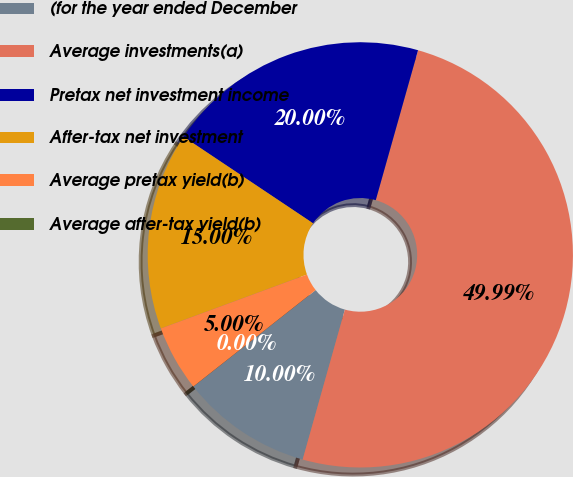Convert chart to OTSL. <chart><loc_0><loc_0><loc_500><loc_500><pie_chart><fcel>(for the year ended December<fcel>Average investments(a)<fcel>Pretax net investment income<fcel>After-tax net investment<fcel>Average pretax yield(b)<fcel>Average after-tax yield(b)<nl><fcel>10.0%<fcel>49.99%<fcel>20.0%<fcel>15.0%<fcel>5.0%<fcel>0.0%<nl></chart> 